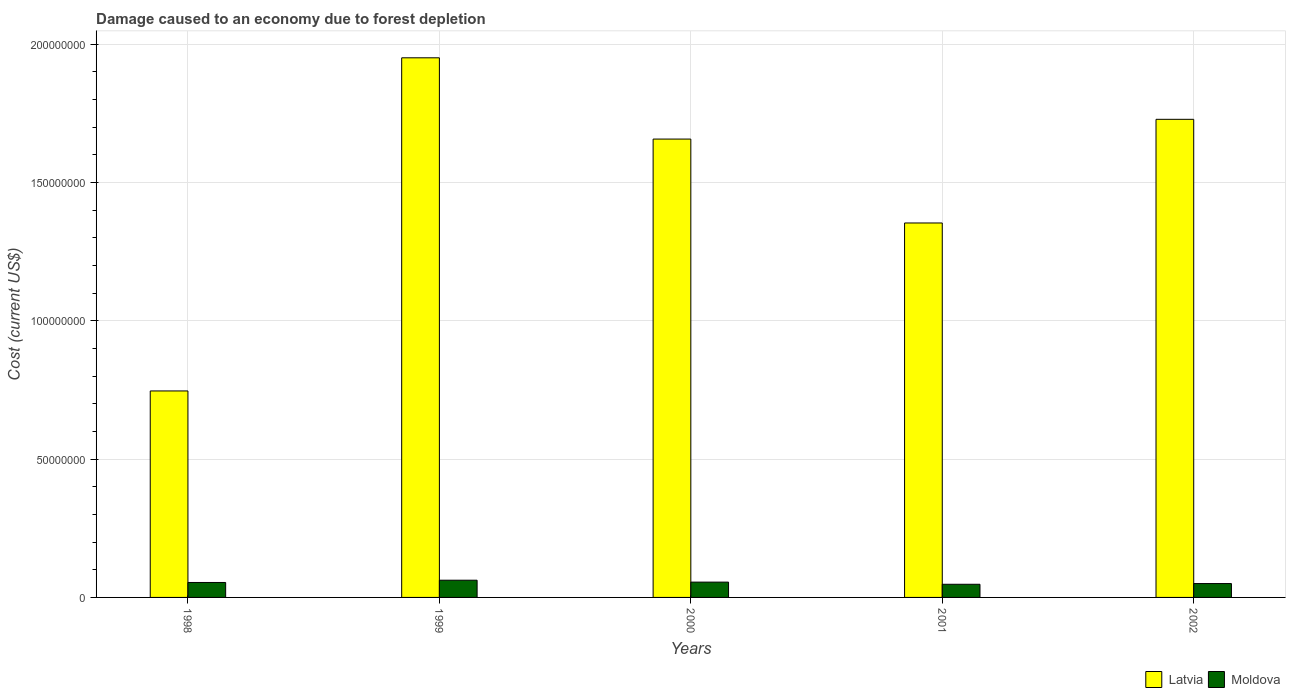Are the number of bars per tick equal to the number of legend labels?
Ensure brevity in your answer.  Yes. Are the number of bars on each tick of the X-axis equal?
Keep it short and to the point. Yes. How many bars are there on the 1st tick from the left?
Your response must be concise. 2. How many bars are there on the 5th tick from the right?
Offer a terse response. 2. What is the label of the 3rd group of bars from the left?
Your answer should be compact. 2000. In how many cases, is the number of bars for a given year not equal to the number of legend labels?
Offer a very short reply. 0. What is the cost of damage caused due to forest depletion in Latvia in 2002?
Your response must be concise. 1.73e+08. Across all years, what is the maximum cost of damage caused due to forest depletion in Latvia?
Provide a short and direct response. 1.95e+08. Across all years, what is the minimum cost of damage caused due to forest depletion in Latvia?
Ensure brevity in your answer.  7.46e+07. In which year was the cost of damage caused due to forest depletion in Latvia maximum?
Offer a terse response. 1999. In which year was the cost of damage caused due to forest depletion in Moldova minimum?
Keep it short and to the point. 2001. What is the total cost of damage caused due to forest depletion in Moldova in the graph?
Your answer should be compact. 2.69e+07. What is the difference between the cost of damage caused due to forest depletion in Moldova in 1999 and that in 2002?
Offer a very short reply. 1.21e+06. What is the difference between the cost of damage caused due to forest depletion in Moldova in 1998 and the cost of damage caused due to forest depletion in Latvia in 2001?
Offer a very short reply. -1.30e+08. What is the average cost of damage caused due to forest depletion in Moldova per year?
Make the answer very short. 5.39e+06. In the year 1998, what is the difference between the cost of damage caused due to forest depletion in Latvia and cost of damage caused due to forest depletion in Moldova?
Your answer should be very brief. 6.92e+07. In how many years, is the cost of damage caused due to forest depletion in Moldova greater than 160000000 US$?
Your response must be concise. 0. What is the ratio of the cost of damage caused due to forest depletion in Moldova in 1998 to that in 2002?
Make the answer very short. 1.08. What is the difference between the highest and the second highest cost of damage caused due to forest depletion in Moldova?
Provide a succinct answer. 6.88e+05. What is the difference between the highest and the lowest cost of damage caused due to forest depletion in Latvia?
Make the answer very short. 1.20e+08. In how many years, is the cost of damage caused due to forest depletion in Latvia greater than the average cost of damage caused due to forest depletion in Latvia taken over all years?
Provide a short and direct response. 3. Is the sum of the cost of damage caused due to forest depletion in Latvia in 2001 and 2002 greater than the maximum cost of damage caused due to forest depletion in Moldova across all years?
Provide a short and direct response. Yes. What does the 2nd bar from the left in 2000 represents?
Make the answer very short. Moldova. What does the 2nd bar from the right in 2002 represents?
Your answer should be compact. Latvia. How many bars are there?
Provide a succinct answer. 10. Are the values on the major ticks of Y-axis written in scientific E-notation?
Ensure brevity in your answer.  No. How many legend labels are there?
Provide a succinct answer. 2. How are the legend labels stacked?
Your response must be concise. Horizontal. What is the title of the graph?
Your answer should be compact. Damage caused to an economy due to forest depletion. What is the label or title of the Y-axis?
Give a very brief answer. Cost (current US$). What is the Cost (current US$) of Latvia in 1998?
Offer a terse response. 7.46e+07. What is the Cost (current US$) in Moldova in 1998?
Your answer should be compact. 5.40e+06. What is the Cost (current US$) of Latvia in 1999?
Provide a succinct answer. 1.95e+08. What is the Cost (current US$) of Moldova in 1999?
Your answer should be compact. 6.22e+06. What is the Cost (current US$) of Latvia in 2000?
Make the answer very short. 1.66e+08. What is the Cost (current US$) of Moldova in 2000?
Make the answer very short. 5.53e+06. What is the Cost (current US$) of Latvia in 2001?
Your response must be concise. 1.35e+08. What is the Cost (current US$) of Moldova in 2001?
Your answer should be compact. 4.76e+06. What is the Cost (current US$) in Latvia in 2002?
Offer a very short reply. 1.73e+08. What is the Cost (current US$) in Moldova in 2002?
Ensure brevity in your answer.  5.01e+06. Across all years, what is the maximum Cost (current US$) in Latvia?
Keep it short and to the point. 1.95e+08. Across all years, what is the maximum Cost (current US$) of Moldova?
Make the answer very short. 6.22e+06. Across all years, what is the minimum Cost (current US$) of Latvia?
Offer a very short reply. 7.46e+07. Across all years, what is the minimum Cost (current US$) in Moldova?
Provide a short and direct response. 4.76e+06. What is the total Cost (current US$) of Latvia in the graph?
Make the answer very short. 7.43e+08. What is the total Cost (current US$) of Moldova in the graph?
Your answer should be very brief. 2.69e+07. What is the difference between the Cost (current US$) of Latvia in 1998 and that in 1999?
Make the answer very short. -1.20e+08. What is the difference between the Cost (current US$) of Moldova in 1998 and that in 1999?
Provide a short and direct response. -8.21e+05. What is the difference between the Cost (current US$) in Latvia in 1998 and that in 2000?
Provide a short and direct response. -9.10e+07. What is the difference between the Cost (current US$) in Moldova in 1998 and that in 2000?
Make the answer very short. -1.33e+05. What is the difference between the Cost (current US$) of Latvia in 1998 and that in 2001?
Your response must be concise. -6.07e+07. What is the difference between the Cost (current US$) in Moldova in 1998 and that in 2001?
Your answer should be very brief. 6.46e+05. What is the difference between the Cost (current US$) of Latvia in 1998 and that in 2002?
Your answer should be compact. -9.82e+07. What is the difference between the Cost (current US$) in Moldova in 1998 and that in 2002?
Your response must be concise. 3.90e+05. What is the difference between the Cost (current US$) of Latvia in 1999 and that in 2000?
Provide a short and direct response. 2.94e+07. What is the difference between the Cost (current US$) of Moldova in 1999 and that in 2000?
Offer a very short reply. 6.88e+05. What is the difference between the Cost (current US$) of Latvia in 1999 and that in 2001?
Make the answer very short. 5.97e+07. What is the difference between the Cost (current US$) in Moldova in 1999 and that in 2001?
Provide a short and direct response. 1.47e+06. What is the difference between the Cost (current US$) of Latvia in 1999 and that in 2002?
Keep it short and to the point. 2.22e+07. What is the difference between the Cost (current US$) of Moldova in 1999 and that in 2002?
Provide a succinct answer. 1.21e+06. What is the difference between the Cost (current US$) of Latvia in 2000 and that in 2001?
Provide a succinct answer. 3.03e+07. What is the difference between the Cost (current US$) of Moldova in 2000 and that in 2001?
Ensure brevity in your answer.  7.79e+05. What is the difference between the Cost (current US$) in Latvia in 2000 and that in 2002?
Give a very brief answer. -7.14e+06. What is the difference between the Cost (current US$) in Moldova in 2000 and that in 2002?
Your answer should be compact. 5.23e+05. What is the difference between the Cost (current US$) in Latvia in 2001 and that in 2002?
Your response must be concise. -3.75e+07. What is the difference between the Cost (current US$) of Moldova in 2001 and that in 2002?
Make the answer very short. -2.56e+05. What is the difference between the Cost (current US$) of Latvia in 1998 and the Cost (current US$) of Moldova in 1999?
Ensure brevity in your answer.  6.84e+07. What is the difference between the Cost (current US$) in Latvia in 1998 and the Cost (current US$) in Moldova in 2000?
Keep it short and to the point. 6.91e+07. What is the difference between the Cost (current US$) in Latvia in 1998 and the Cost (current US$) in Moldova in 2001?
Your response must be concise. 6.99e+07. What is the difference between the Cost (current US$) in Latvia in 1998 and the Cost (current US$) in Moldova in 2002?
Your answer should be compact. 6.96e+07. What is the difference between the Cost (current US$) of Latvia in 1999 and the Cost (current US$) of Moldova in 2000?
Your answer should be very brief. 1.89e+08. What is the difference between the Cost (current US$) of Latvia in 1999 and the Cost (current US$) of Moldova in 2001?
Make the answer very short. 1.90e+08. What is the difference between the Cost (current US$) of Latvia in 1999 and the Cost (current US$) of Moldova in 2002?
Offer a very short reply. 1.90e+08. What is the difference between the Cost (current US$) in Latvia in 2000 and the Cost (current US$) in Moldova in 2001?
Keep it short and to the point. 1.61e+08. What is the difference between the Cost (current US$) of Latvia in 2000 and the Cost (current US$) of Moldova in 2002?
Offer a terse response. 1.61e+08. What is the difference between the Cost (current US$) in Latvia in 2001 and the Cost (current US$) in Moldova in 2002?
Your answer should be compact. 1.30e+08. What is the average Cost (current US$) in Latvia per year?
Provide a succinct answer. 1.49e+08. What is the average Cost (current US$) of Moldova per year?
Provide a short and direct response. 5.39e+06. In the year 1998, what is the difference between the Cost (current US$) in Latvia and Cost (current US$) in Moldova?
Your answer should be very brief. 6.92e+07. In the year 1999, what is the difference between the Cost (current US$) of Latvia and Cost (current US$) of Moldova?
Keep it short and to the point. 1.89e+08. In the year 2000, what is the difference between the Cost (current US$) in Latvia and Cost (current US$) in Moldova?
Make the answer very short. 1.60e+08. In the year 2001, what is the difference between the Cost (current US$) in Latvia and Cost (current US$) in Moldova?
Offer a very short reply. 1.31e+08. In the year 2002, what is the difference between the Cost (current US$) of Latvia and Cost (current US$) of Moldova?
Your answer should be very brief. 1.68e+08. What is the ratio of the Cost (current US$) in Latvia in 1998 to that in 1999?
Your answer should be compact. 0.38. What is the ratio of the Cost (current US$) in Moldova in 1998 to that in 1999?
Offer a very short reply. 0.87. What is the ratio of the Cost (current US$) in Latvia in 1998 to that in 2000?
Offer a terse response. 0.45. What is the ratio of the Cost (current US$) of Moldova in 1998 to that in 2000?
Keep it short and to the point. 0.98. What is the ratio of the Cost (current US$) of Latvia in 1998 to that in 2001?
Provide a succinct answer. 0.55. What is the ratio of the Cost (current US$) of Moldova in 1998 to that in 2001?
Your answer should be very brief. 1.14. What is the ratio of the Cost (current US$) in Latvia in 1998 to that in 2002?
Your answer should be very brief. 0.43. What is the ratio of the Cost (current US$) in Moldova in 1998 to that in 2002?
Offer a terse response. 1.08. What is the ratio of the Cost (current US$) of Latvia in 1999 to that in 2000?
Make the answer very short. 1.18. What is the ratio of the Cost (current US$) in Moldova in 1999 to that in 2000?
Provide a short and direct response. 1.12. What is the ratio of the Cost (current US$) in Latvia in 1999 to that in 2001?
Make the answer very short. 1.44. What is the ratio of the Cost (current US$) of Moldova in 1999 to that in 2001?
Provide a succinct answer. 1.31. What is the ratio of the Cost (current US$) of Latvia in 1999 to that in 2002?
Ensure brevity in your answer.  1.13. What is the ratio of the Cost (current US$) of Moldova in 1999 to that in 2002?
Offer a very short reply. 1.24. What is the ratio of the Cost (current US$) of Latvia in 2000 to that in 2001?
Keep it short and to the point. 1.22. What is the ratio of the Cost (current US$) in Moldova in 2000 to that in 2001?
Provide a short and direct response. 1.16. What is the ratio of the Cost (current US$) of Latvia in 2000 to that in 2002?
Your response must be concise. 0.96. What is the ratio of the Cost (current US$) in Moldova in 2000 to that in 2002?
Your response must be concise. 1.1. What is the ratio of the Cost (current US$) of Latvia in 2001 to that in 2002?
Your response must be concise. 0.78. What is the ratio of the Cost (current US$) of Moldova in 2001 to that in 2002?
Keep it short and to the point. 0.95. What is the difference between the highest and the second highest Cost (current US$) in Latvia?
Give a very brief answer. 2.22e+07. What is the difference between the highest and the second highest Cost (current US$) in Moldova?
Give a very brief answer. 6.88e+05. What is the difference between the highest and the lowest Cost (current US$) in Latvia?
Offer a terse response. 1.20e+08. What is the difference between the highest and the lowest Cost (current US$) in Moldova?
Your answer should be very brief. 1.47e+06. 